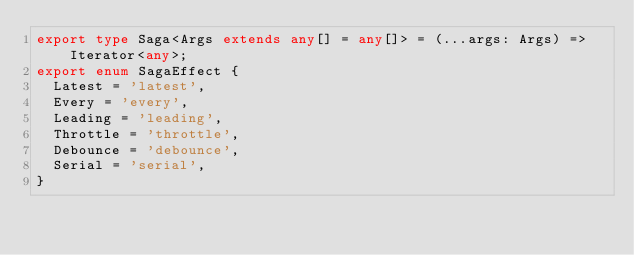<code> <loc_0><loc_0><loc_500><loc_500><_TypeScript_>export type Saga<Args extends any[] = any[]> = (...args: Args) => Iterator<any>;
export enum SagaEffect {
  Latest = 'latest',
  Every = 'every',
  Leading = 'leading',
  Throttle = 'throttle',
  Debounce = 'debounce',
  Serial = 'serial',
}
</code> 